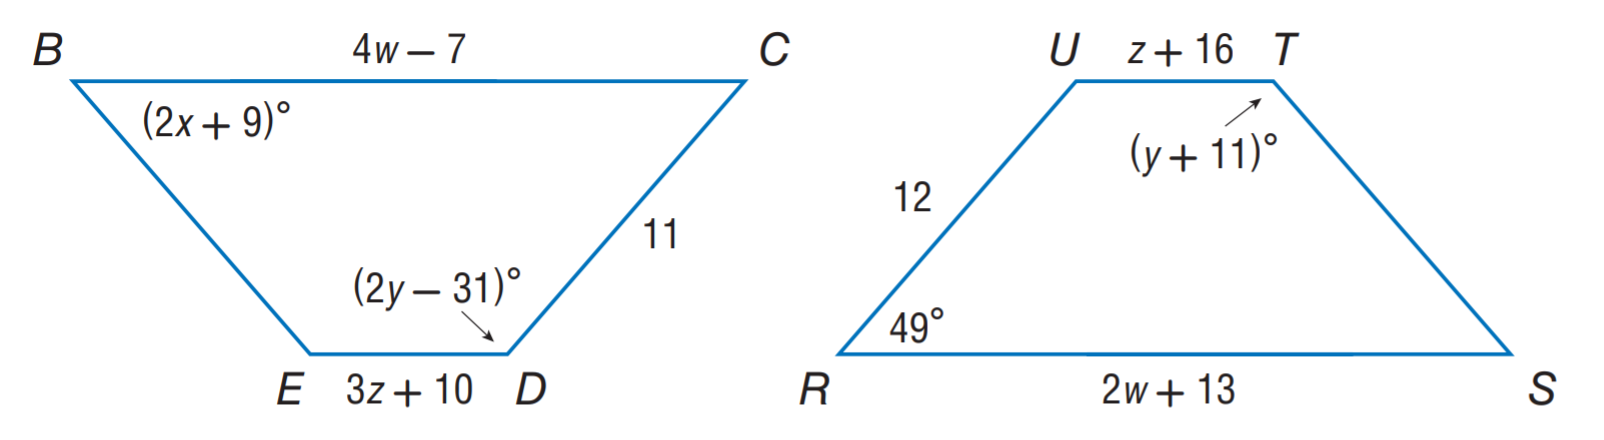Question: Polygon B C D E \cong polygon R S T U. Find x.
Choices:
A. 3
B. 10
C. 20
D. 42
Answer with the letter. Answer: C Question: Polygon B C D E \cong polygon R S T U. Find z.
Choices:
A. 3
B. 10
C. 20
D. 42
Answer with the letter. Answer: A Question: Polygon B C D E \cong polygon R S T U. Find w.
Choices:
A. 3
B. 10
C. 20
D. 42
Answer with the letter. Answer: B Question: Polygon B C D E \cong polygon R S T U. Find y.
Choices:
A. 3
B. 10
C. 20
D. 42
Answer with the letter. Answer: D 